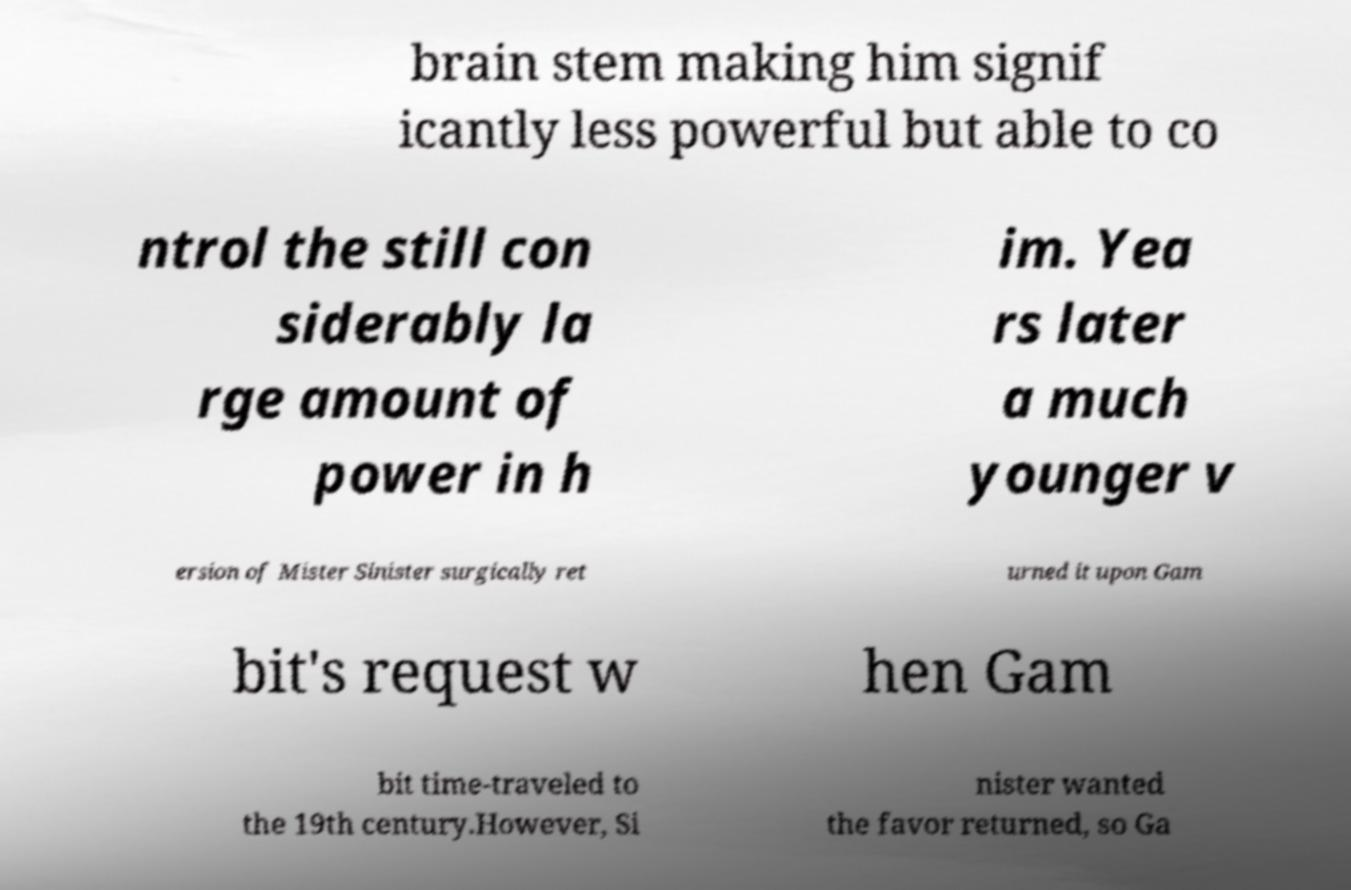I need the written content from this picture converted into text. Can you do that? brain stem making him signif icantly less powerful but able to co ntrol the still con siderably la rge amount of power in h im. Yea rs later a much younger v ersion of Mister Sinister surgically ret urned it upon Gam bit's request w hen Gam bit time-traveled to the 19th century.However, Si nister wanted the favor returned, so Ga 